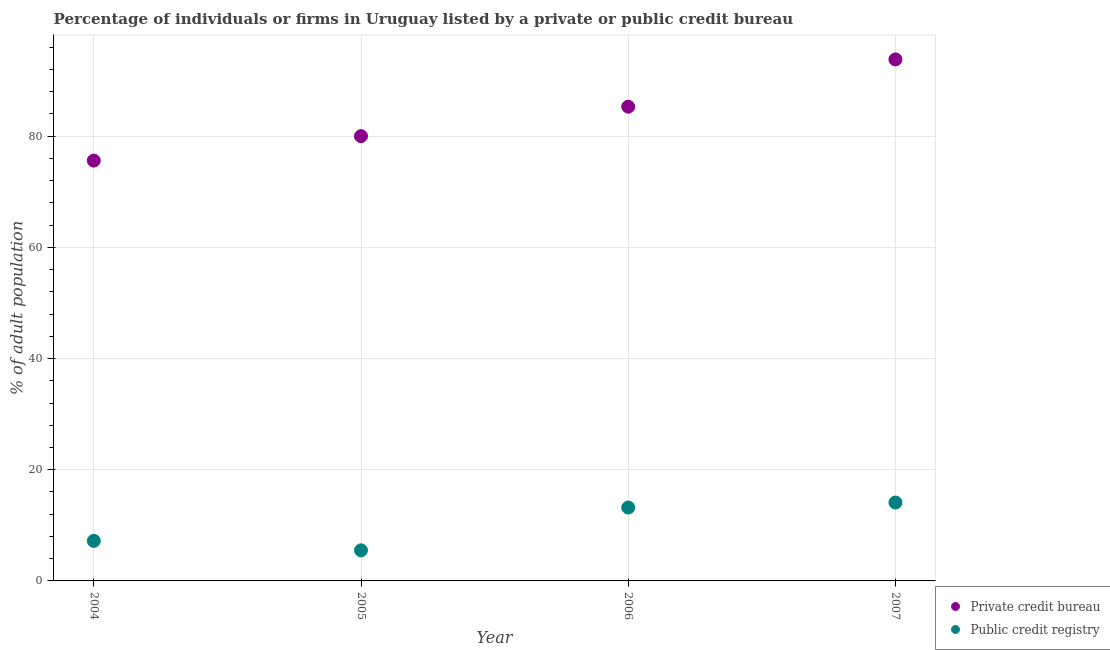How many different coloured dotlines are there?
Provide a succinct answer. 2. What is the percentage of firms listed by private credit bureau in 2006?
Keep it short and to the point. 85.3. Across all years, what is the maximum percentage of firms listed by private credit bureau?
Your response must be concise. 93.8. Across all years, what is the minimum percentage of firms listed by private credit bureau?
Make the answer very short. 75.6. In which year was the percentage of firms listed by public credit bureau minimum?
Provide a short and direct response. 2005. What is the total percentage of firms listed by private credit bureau in the graph?
Offer a terse response. 334.7. What is the difference between the percentage of firms listed by public credit bureau in 2004 and that in 2006?
Your answer should be compact. -6. What is the difference between the percentage of firms listed by private credit bureau in 2007 and the percentage of firms listed by public credit bureau in 2006?
Offer a terse response. 80.6. What is the average percentage of firms listed by private credit bureau per year?
Offer a very short reply. 83.67. In the year 2007, what is the difference between the percentage of firms listed by public credit bureau and percentage of firms listed by private credit bureau?
Ensure brevity in your answer.  -79.7. In how many years, is the percentage of firms listed by private credit bureau greater than 28 %?
Your response must be concise. 4. What is the ratio of the percentage of firms listed by private credit bureau in 2004 to that in 2005?
Ensure brevity in your answer.  0.94. Is the percentage of firms listed by public credit bureau in 2004 less than that in 2007?
Keep it short and to the point. Yes. What is the difference between the highest and the lowest percentage of firms listed by public credit bureau?
Give a very brief answer. 8.6. Is the sum of the percentage of firms listed by public credit bureau in 2005 and 2006 greater than the maximum percentage of firms listed by private credit bureau across all years?
Your answer should be very brief. No. Is the percentage of firms listed by private credit bureau strictly less than the percentage of firms listed by public credit bureau over the years?
Keep it short and to the point. No. How many years are there in the graph?
Provide a succinct answer. 4. What is the difference between two consecutive major ticks on the Y-axis?
Provide a succinct answer. 20. Are the values on the major ticks of Y-axis written in scientific E-notation?
Your response must be concise. No. Where does the legend appear in the graph?
Provide a succinct answer. Bottom right. How are the legend labels stacked?
Your answer should be compact. Vertical. What is the title of the graph?
Offer a terse response. Percentage of individuals or firms in Uruguay listed by a private or public credit bureau. What is the label or title of the X-axis?
Provide a succinct answer. Year. What is the label or title of the Y-axis?
Keep it short and to the point. % of adult population. What is the % of adult population in Private credit bureau in 2004?
Provide a short and direct response. 75.6. What is the % of adult population of Public credit registry in 2004?
Your answer should be compact. 7.2. What is the % of adult population in Public credit registry in 2005?
Your answer should be compact. 5.5. What is the % of adult population of Private credit bureau in 2006?
Your answer should be very brief. 85.3. What is the % of adult population of Public credit registry in 2006?
Make the answer very short. 13.2. What is the % of adult population of Private credit bureau in 2007?
Your response must be concise. 93.8. What is the % of adult population of Public credit registry in 2007?
Offer a terse response. 14.1. Across all years, what is the maximum % of adult population in Private credit bureau?
Your answer should be compact. 93.8. Across all years, what is the minimum % of adult population of Private credit bureau?
Your response must be concise. 75.6. What is the total % of adult population of Private credit bureau in the graph?
Provide a short and direct response. 334.7. What is the total % of adult population of Public credit registry in the graph?
Your response must be concise. 40. What is the difference between the % of adult population of Public credit registry in 2004 and that in 2005?
Offer a terse response. 1.7. What is the difference between the % of adult population in Private credit bureau in 2004 and that in 2007?
Your response must be concise. -18.2. What is the difference between the % of adult population in Private credit bureau in 2005 and that in 2006?
Ensure brevity in your answer.  -5.3. What is the difference between the % of adult population in Private credit bureau in 2005 and that in 2007?
Your answer should be very brief. -13.8. What is the difference between the % of adult population in Public credit registry in 2005 and that in 2007?
Offer a very short reply. -8.6. What is the difference between the % of adult population of Private credit bureau in 2006 and that in 2007?
Keep it short and to the point. -8.5. What is the difference between the % of adult population of Private credit bureau in 2004 and the % of adult population of Public credit registry in 2005?
Your answer should be very brief. 70.1. What is the difference between the % of adult population of Private credit bureau in 2004 and the % of adult population of Public credit registry in 2006?
Your answer should be compact. 62.4. What is the difference between the % of adult population in Private credit bureau in 2004 and the % of adult population in Public credit registry in 2007?
Keep it short and to the point. 61.5. What is the difference between the % of adult population in Private credit bureau in 2005 and the % of adult population in Public credit registry in 2006?
Your answer should be very brief. 66.8. What is the difference between the % of adult population in Private credit bureau in 2005 and the % of adult population in Public credit registry in 2007?
Provide a short and direct response. 65.9. What is the difference between the % of adult population of Private credit bureau in 2006 and the % of adult population of Public credit registry in 2007?
Keep it short and to the point. 71.2. What is the average % of adult population of Private credit bureau per year?
Offer a very short reply. 83.67. What is the average % of adult population in Public credit registry per year?
Ensure brevity in your answer.  10. In the year 2004, what is the difference between the % of adult population of Private credit bureau and % of adult population of Public credit registry?
Provide a succinct answer. 68.4. In the year 2005, what is the difference between the % of adult population of Private credit bureau and % of adult population of Public credit registry?
Your answer should be very brief. 74.5. In the year 2006, what is the difference between the % of adult population in Private credit bureau and % of adult population in Public credit registry?
Make the answer very short. 72.1. In the year 2007, what is the difference between the % of adult population of Private credit bureau and % of adult population of Public credit registry?
Offer a very short reply. 79.7. What is the ratio of the % of adult population in Private credit bureau in 2004 to that in 2005?
Your answer should be compact. 0.94. What is the ratio of the % of adult population in Public credit registry in 2004 to that in 2005?
Offer a terse response. 1.31. What is the ratio of the % of adult population in Private credit bureau in 2004 to that in 2006?
Your answer should be very brief. 0.89. What is the ratio of the % of adult population in Public credit registry in 2004 to that in 2006?
Keep it short and to the point. 0.55. What is the ratio of the % of adult population of Private credit bureau in 2004 to that in 2007?
Provide a short and direct response. 0.81. What is the ratio of the % of adult population of Public credit registry in 2004 to that in 2007?
Your response must be concise. 0.51. What is the ratio of the % of adult population of Private credit bureau in 2005 to that in 2006?
Your answer should be compact. 0.94. What is the ratio of the % of adult population in Public credit registry in 2005 to that in 2006?
Keep it short and to the point. 0.42. What is the ratio of the % of adult population in Private credit bureau in 2005 to that in 2007?
Provide a short and direct response. 0.85. What is the ratio of the % of adult population in Public credit registry in 2005 to that in 2007?
Ensure brevity in your answer.  0.39. What is the ratio of the % of adult population of Private credit bureau in 2006 to that in 2007?
Make the answer very short. 0.91. What is the ratio of the % of adult population in Public credit registry in 2006 to that in 2007?
Your answer should be compact. 0.94. What is the difference between the highest and the second highest % of adult population in Private credit bureau?
Provide a succinct answer. 8.5. What is the difference between the highest and the second highest % of adult population of Public credit registry?
Your answer should be very brief. 0.9. What is the difference between the highest and the lowest % of adult population in Private credit bureau?
Your answer should be compact. 18.2. 